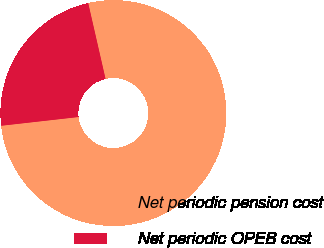Convert chart. <chart><loc_0><loc_0><loc_500><loc_500><pie_chart><fcel>Net periodic pension cost<fcel>Net periodic OPEB cost<nl><fcel>76.79%<fcel>23.21%<nl></chart> 